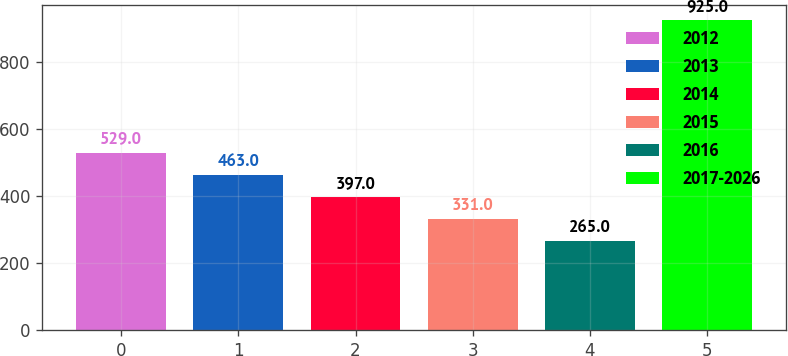Convert chart. <chart><loc_0><loc_0><loc_500><loc_500><bar_chart><fcel>2012<fcel>2013<fcel>2014<fcel>2015<fcel>2016<fcel>2017-2026<nl><fcel>529<fcel>463<fcel>397<fcel>331<fcel>265<fcel>925<nl></chart> 